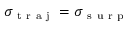Convert formula to latex. <formula><loc_0><loc_0><loc_500><loc_500>\sigma _ { t r a j } = \sigma _ { s u r p }</formula> 